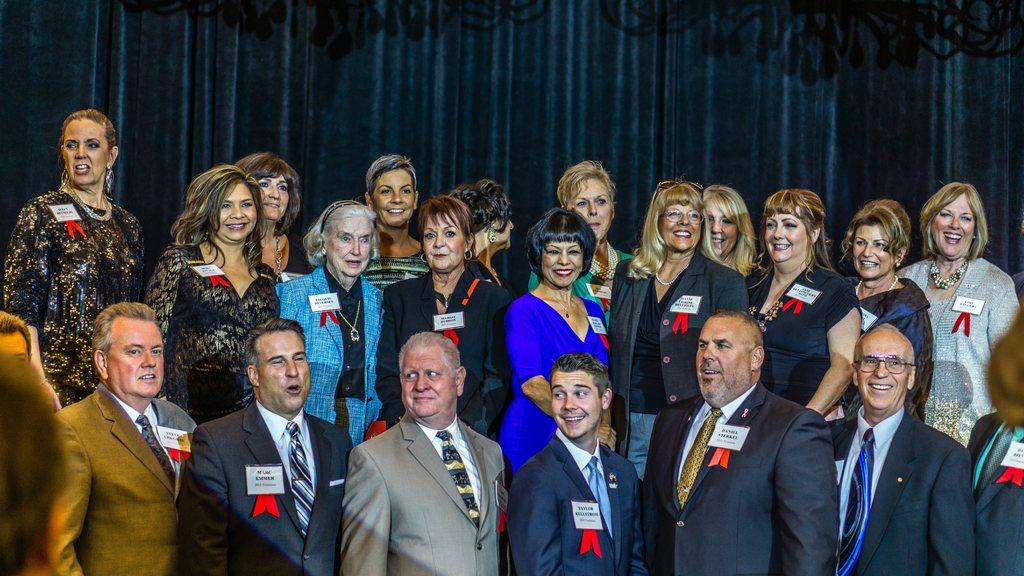How many people are in the image? There is a group of people standing in the image, but the exact number is not specified. What can be seen in the background of the image? There is a curtain in the image. Who is wearing the crown in the image? There is no crown present in the image. What type of worm can be seen crawling on the curtain in the image? There are no worms present in the image. 